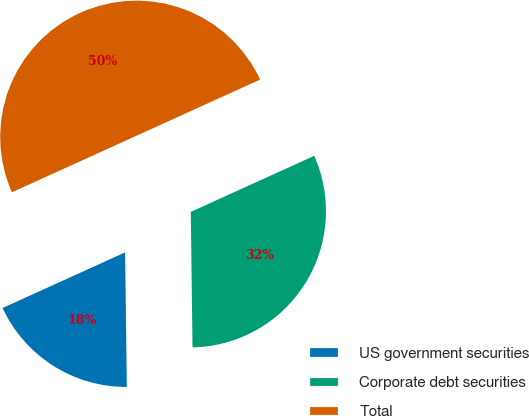Convert chart. <chart><loc_0><loc_0><loc_500><loc_500><pie_chart><fcel>US government securities<fcel>Corporate debt securities<fcel>Total<nl><fcel>18.42%<fcel>31.58%<fcel>50.0%<nl></chart> 